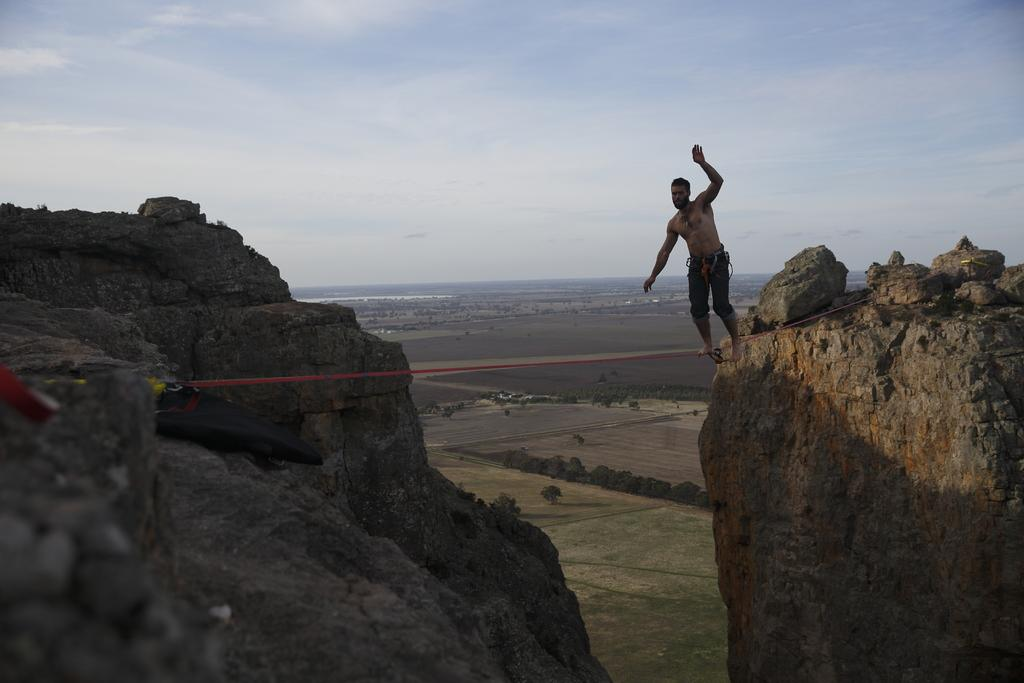What is the man in the image doing? The man is walking on a rope in the image. What type of landscape can be seen in the image? Hills are visible in the image. What objects are present in the image? There are objects in the image, but their specific nature is not mentioned in the facts. What can be seen in the background of the image? Trees, grass, and the sky are visible in the background of the image. What type of tub is visible in the image? There is no tub present in the image. What is the coil used for in the image? There is no coil present in the image. 